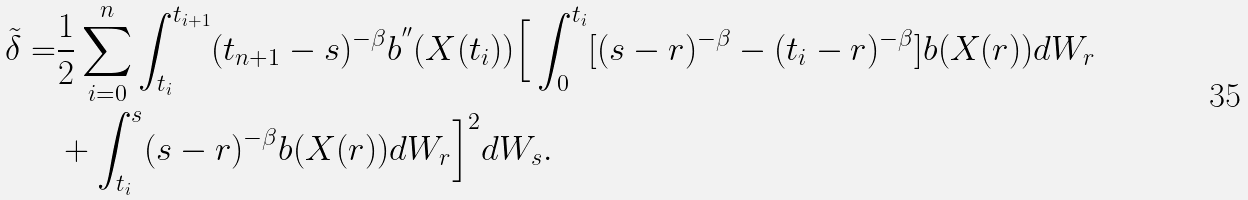<formula> <loc_0><loc_0><loc_500><loc_500>\tilde { \delta } = & \frac { 1 } { 2 } \sum _ { i = 0 } ^ { n } \int _ { t _ { i } } ^ { t _ { i + 1 } } ( t _ { n + 1 } - s ) ^ { - \beta } b ^ { ^ { \prime \prime } } ( X ( t _ { i } ) ) \Big { [ } \int _ { 0 } ^ { t _ { i } } [ ( s - r ) ^ { - \beta } - ( t _ { i } - r ) ^ { - \beta } ] b ( X ( r ) ) d W _ { r } \\ & + \int _ { t _ { i } } ^ { s } ( s - r ) ^ { - \beta } b ( X ( r ) ) d W _ { r } \Big { ] } ^ { 2 } d W _ { s } .</formula> 